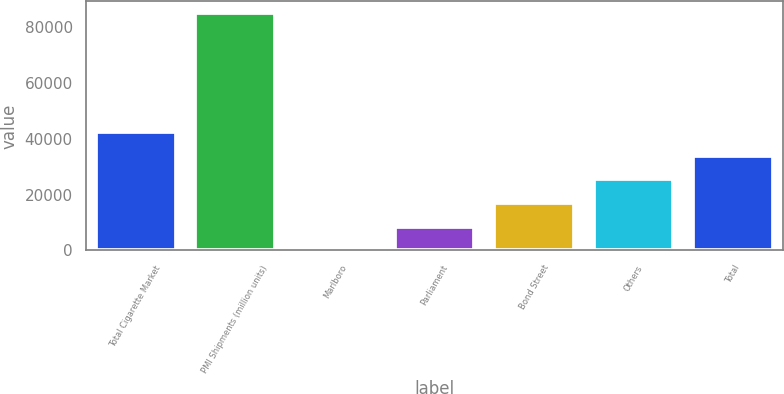Convert chart. <chart><loc_0><loc_0><loc_500><loc_500><bar_chart><fcel>Total Cigarette Market<fcel>PMI Shipments (million units)<fcel>Marlboro<fcel>Parliament<fcel>Bond Street<fcel>Others<fcel>Total<nl><fcel>42474.8<fcel>84948<fcel>1.6<fcel>8496.24<fcel>16990.9<fcel>25485.5<fcel>33980.2<nl></chart> 